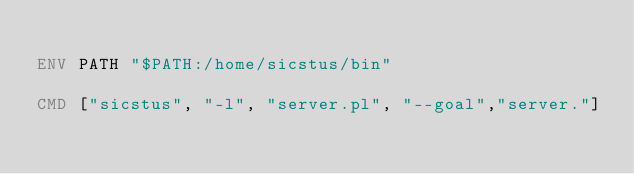<code> <loc_0><loc_0><loc_500><loc_500><_Dockerfile_>
ENV PATH "$PATH:/home/sicstus/bin"

CMD ["sicstus", "-l", "server.pl", "--goal","server."]</code> 